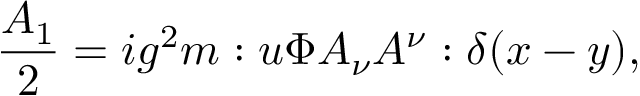Convert formula to latex. <formula><loc_0><loc_0><loc_500><loc_500>\frac { A _ { 1 } } { 2 } = i g ^ { 2 } m \colon u \Phi A _ { \nu } A ^ { \nu } \colon \delta ( x - y ) ,</formula> 